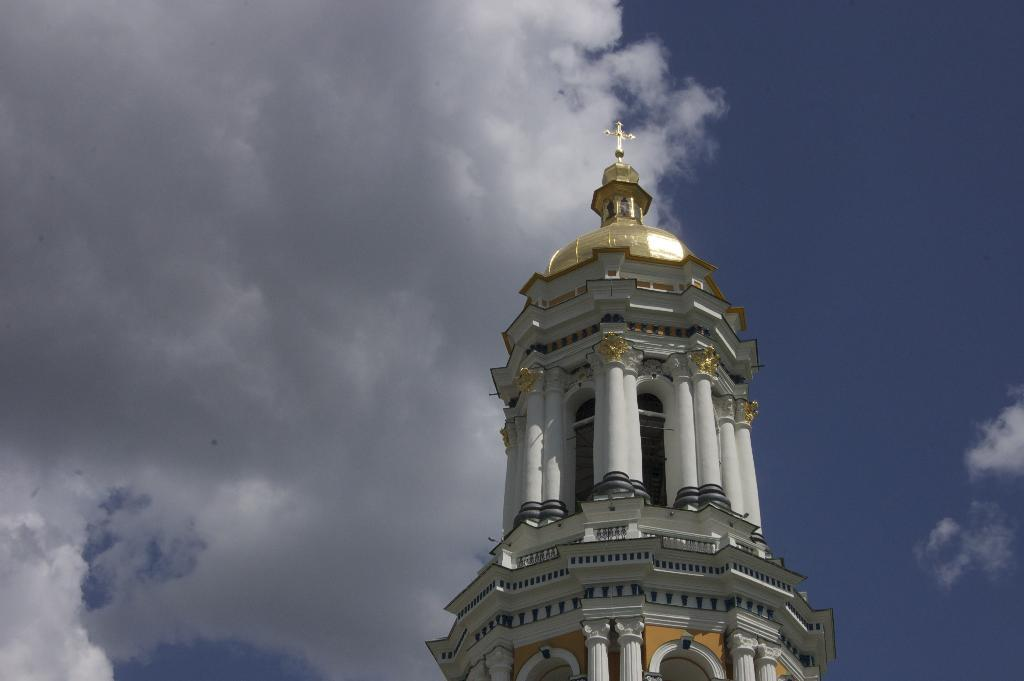What type of structure is at the bottom of the image? There is a building tower in the image. Where is the building tower located in relation to the image? The building tower is at the bottom of the image. What can be seen in the background of the image? The sky is visible in the background of the image. How would you describe the sky in the image? The sky appears to be cloudy. What type of pail is hanging from the building tower in the image? There is no pail present in the image; it only features a building tower and a cloudy sky. What nation is depicted in the image? The image does not depict any specific nation; it only shows a building tower and a cloudy sky. 